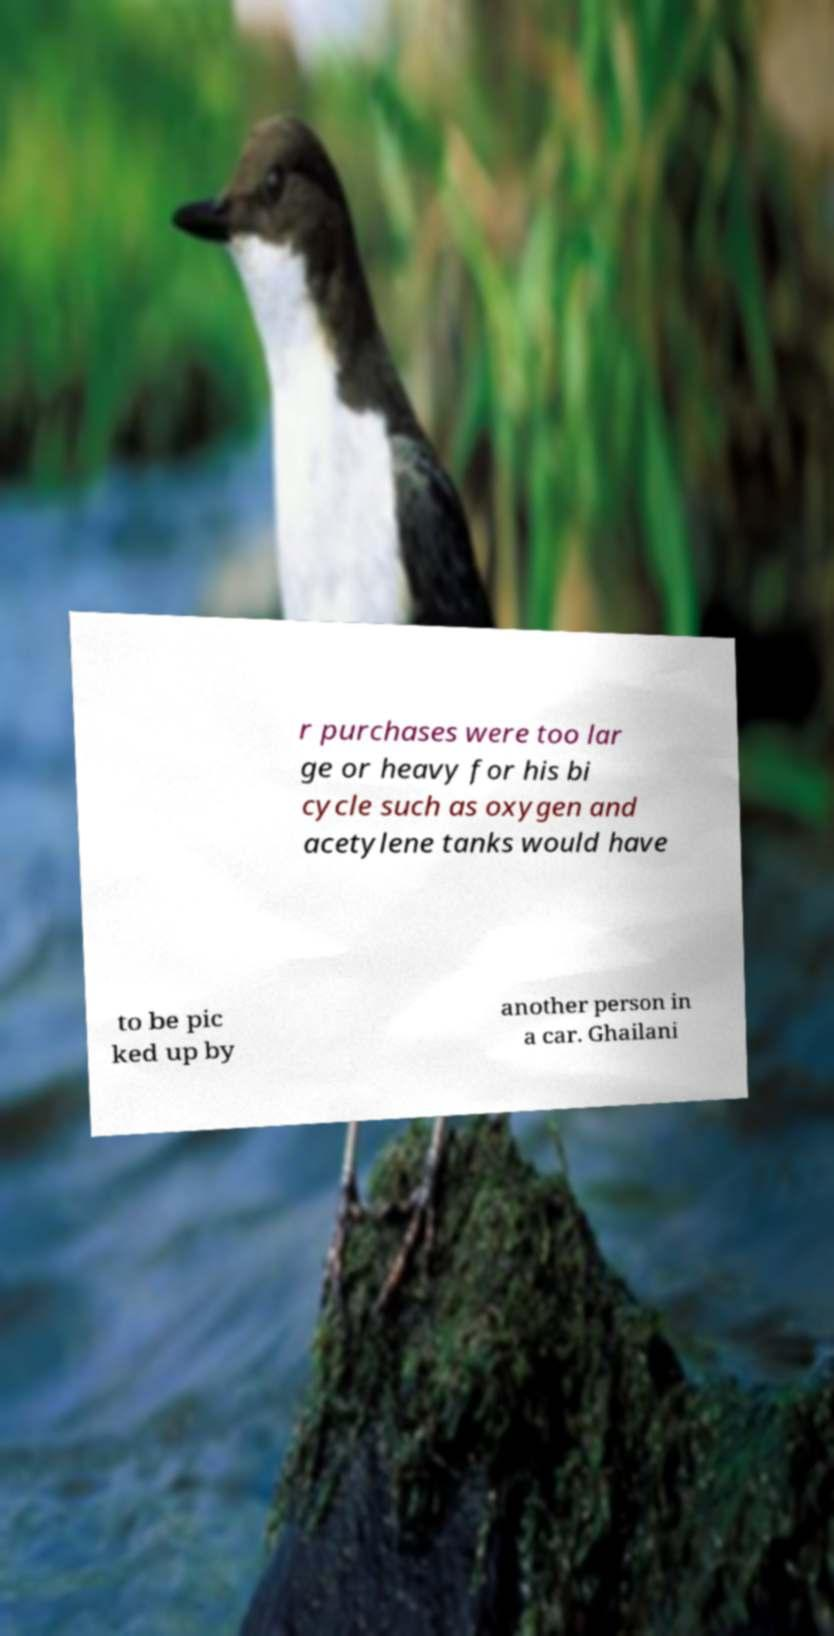Please read and relay the text visible in this image. What does it say? r purchases were too lar ge or heavy for his bi cycle such as oxygen and acetylene tanks would have to be pic ked up by another person in a car. Ghailani 